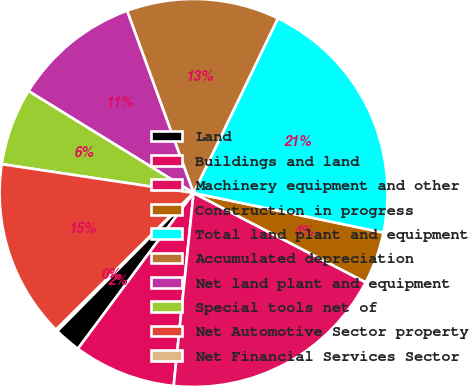Convert chart to OTSL. <chart><loc_0><loc_0><loc_500><loc_500><pie_chart><fcel>Land<fcel>Buildings and land<fcel>Machinery equipment and other<fcel>Construction in progress<fcel>Total land plant and equipment<fcel>Accumulated depreciation<fcel>Net land plant and equipment<fcel>Special tools net of<fcel>Net Automotive Sector property<fcel>Net Financial Services Sector<nl><fcel>2.24%<fcel>8.53%<fcel>19.02%<fcel>4.34%<fcel>21.12%<fcel>12.73%<fcel>10.63%<fcel>6.43%<fcel>14.83%<fcel>0.14%<nl></chart> 